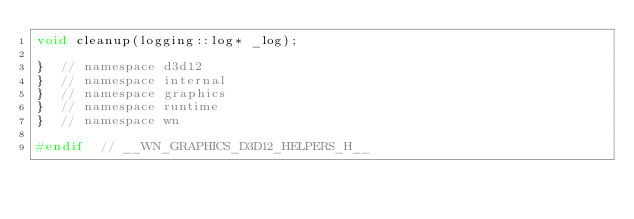Convert code to text. <code><loc_0><loc_0><loc_500><loc_500><_C_>void cleanup(logging::log* _log);

}  // namespace d3d12
}  // namespace internal
}  // namespace graphics
}  // namespace runtime
}  // namespace wn

#endif  // __WN_GRAPHICS_D3D12_HELPERS_H__
</code> 